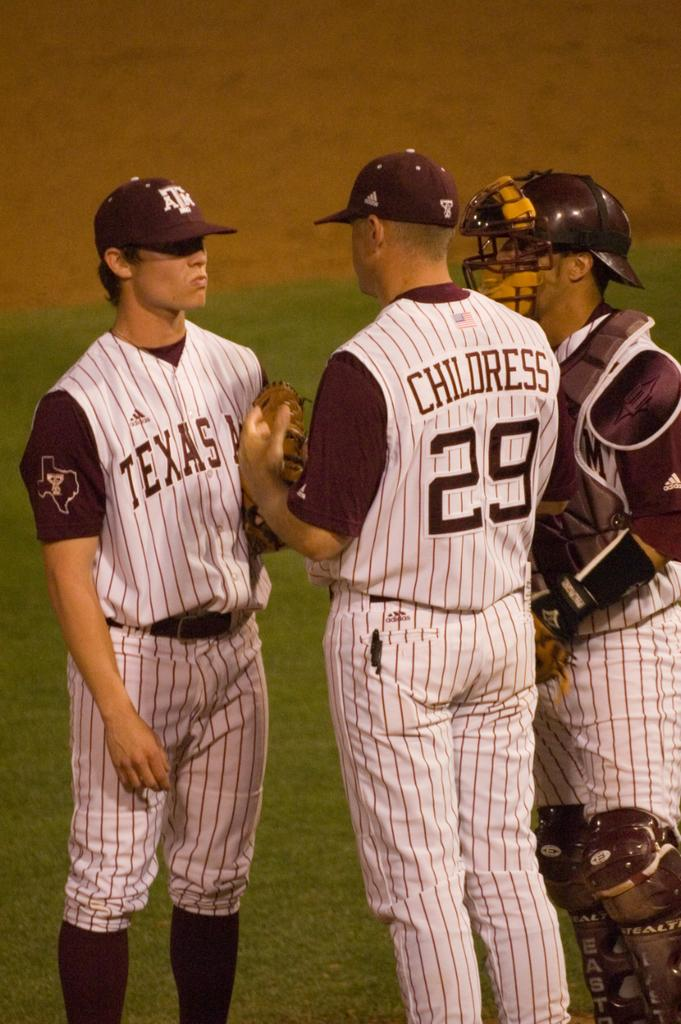Provide a one-sentence caption for the provided image. Three Baseball player from Texas A&M having a conversation. 